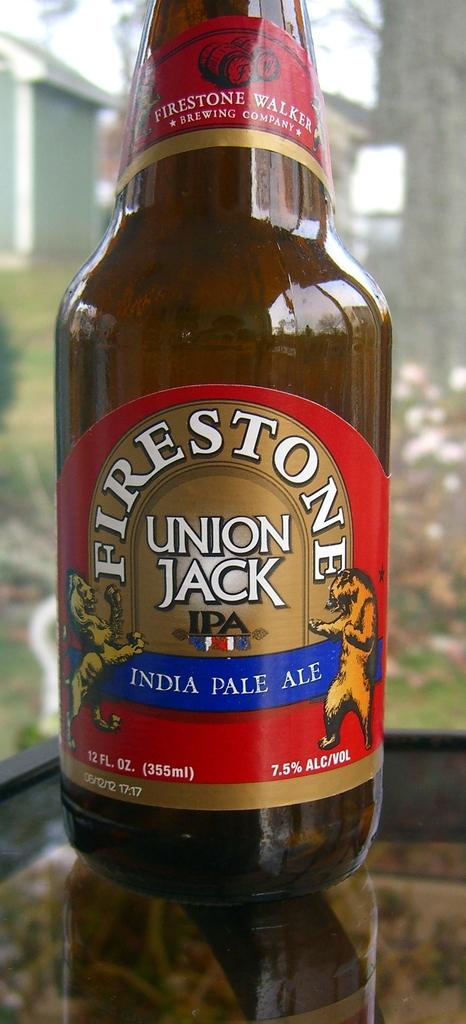<image>
Write a terse but informative summary of the picture. A bottle of Firestone Indian ale is on a glass table. 